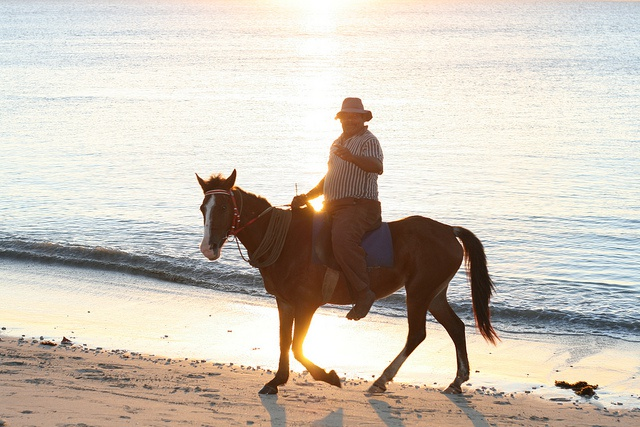Describe the objects in this image and their specific colors. I can see horse in lightgray, maroon, black, and brown tones and people in lightgray, maroon, gray, and brown tones in this image. 